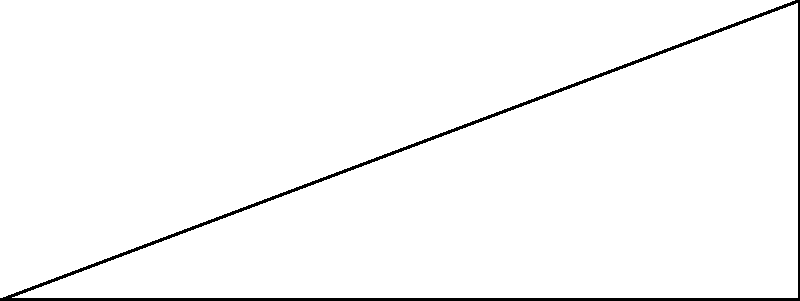At Daytona International Speedway, engineers are redesigning the pit stop lane. The new design forms a right-angled triangle with the main track. If the angle between the pit lane and the main track is 30°, and the length of the main track segment adjacent to the pit lane is 8 cm (on the diagram scale), what is the length of the pit lane (x) to the nearest centimeter? Let's approach this step-by-step using the Pythagorean theorem and inverse trigonometric functions:

1) In the right-angled triangle ABC, we know:
   - Angle BAC = 30°
   - AB (adjacent to the angle) = 8 cm
   - We need to find BC (opposite to the angle)

2) We can use the tangent function:
   $\tan 30° = \frac{opposite}{adjacent} = \frac{BC}{AB} = \frac{x}{8}$

3) We know that $\tan 30° = \frac{1}{\sqrt{3}}$, so:
   $\frac{1}{\sqrt{3}} = \frac{x}{8}$

4) Cross multiply:
   $8 = x\sqrt{3}$

5) Solve for x:
   $x = \frac{8}{\sqrt{3}}$

6) Simplify:
   $x = \frac{8}{\sqrt{3}} \cdot \frac{\sqrt{3}}{\sqrt{3}} = \frac{8\sqrt{3}}{3} \approx 4.62$ cm

7) Rounding to the nearest centimeter:
   x ≈ 5 cm

Therefore, the length of the pit lane is approximately 5 cm on the diagram scale.
Answer: 5 cm 